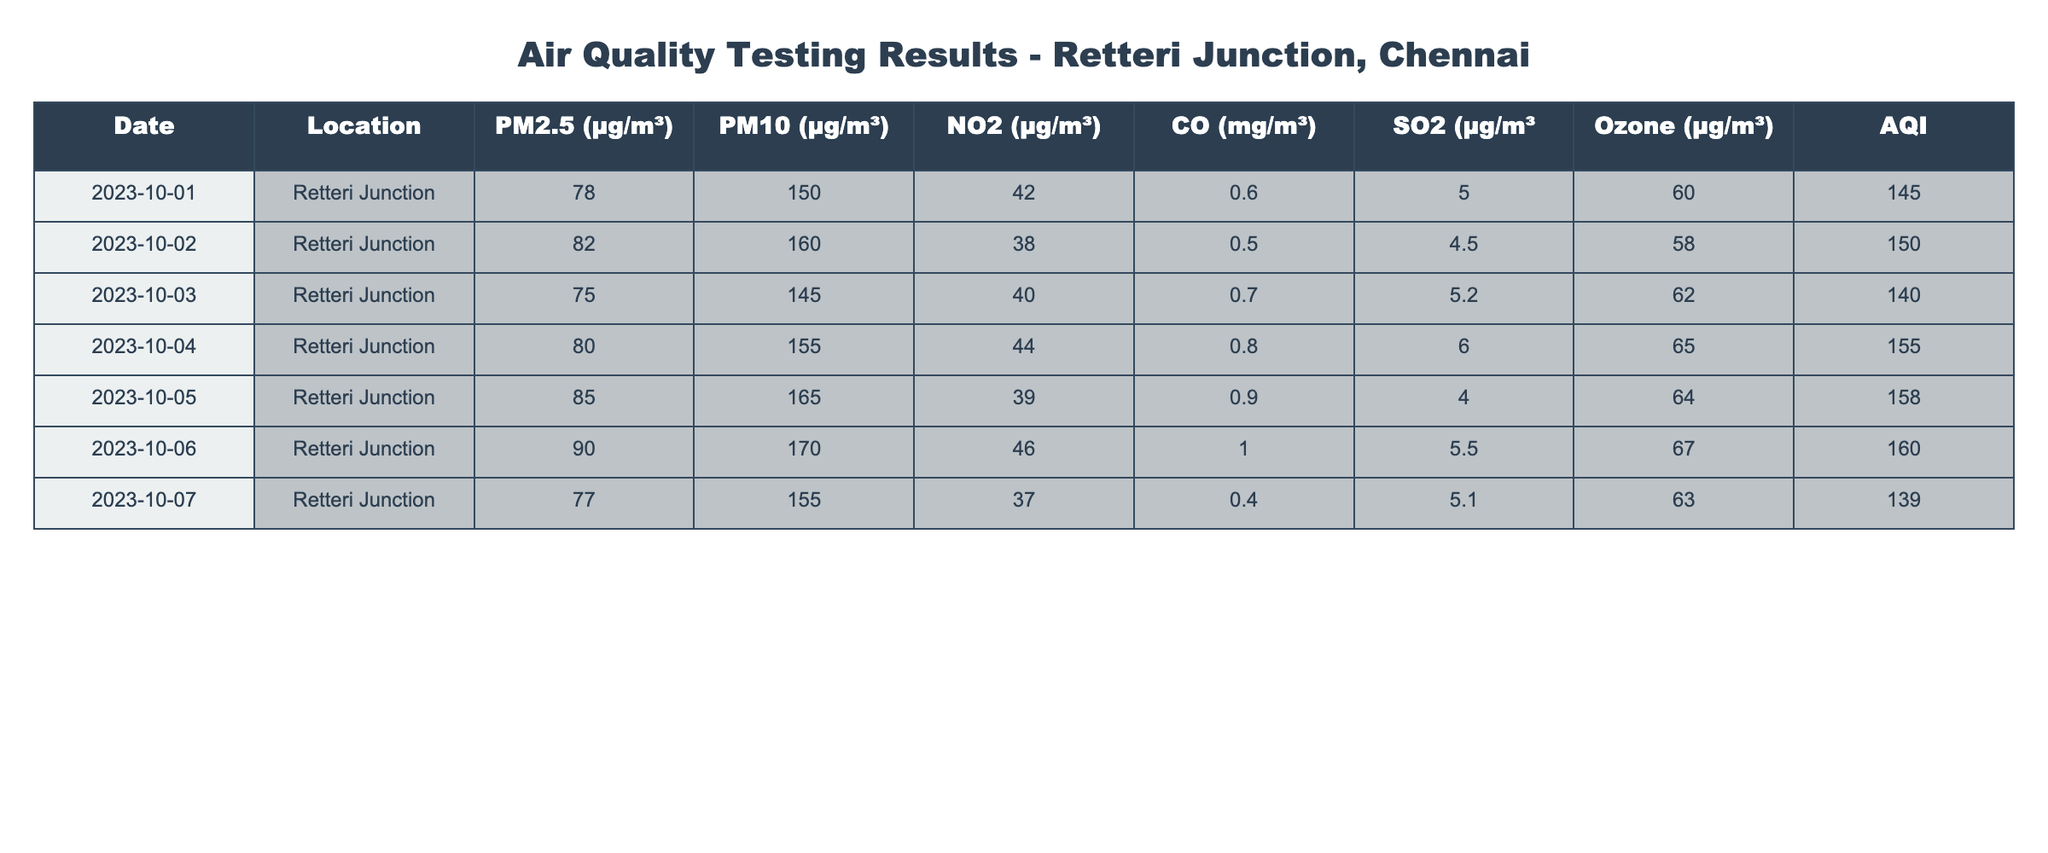What is the highest recorded PM2.5 level at Retteri Junction? The table lists PM2.5 values for each date. The highest value can be found by scanning the PM2.5 column row by row, which shows that the maximum PM2.5 concentration recorded is 90 µg/m³ on October 6, 2023.
Answer: 90 µg/m³ During which date was the AQI the highest? The AQI column needs to be checked for the date with the highest value. Scanning through the AQI values reveals that October 6, 2023, has the highest AQI at 160.
Answer: October 6, 2023 What is the average PM10 value for the recorded days? To find the average, add all PM10 values together (150 + 160 + 145 + 155 + 165 + 170 + 155 = 1,100) and divide by the number of entries (7). Thus, 1,100 / 7 = approximately 157.14.
Answer: 157.14 µg/m³ Is the average NO2 level above 40 µg/m³? First, sum the NO2 values (42 + 38 + 40 + 44 + 39 + 46 + 37 = 286) and then divide by the number of entries (7). This results in an average of 286 / 7 = 40.86. The average is indeed above 40 µg/m³.
Answer: Yes What was the CO level on October 3, 2023, and how does it compare to the CO level on October 1, 2023? The CO levels for October 3, 2023, and October 1, 2023, are 0.7 mg/m³ and 0.6 mg/m³ respectively. To compare: 0.7 mg/m³ (October 3) is higher than 0.6 mg/m³ (October 1) by 0.1 mg/m³.
Answer: 0.7 mg/m³, higher by 0.1 mg/m³ What is the total concentration of SO2 recorded over the testing days? Summing up the SO2 values (5 + 4.5 + 5.2 + 6 + 4 + 5.5 + 5.1 = 35.3) gives the total concentration of SO2 over seven days.
Answer: 35.3 µg/m³ On which days was the Ozone level above 60 µg/m³? By examining the Ozone column, the days with levels above 60 µg/m³ are October 4 (65), October 5 (64), and October 6 (67). These data points indicate three specific days when Ozone exceeded 60 µg/m³.
Answer: October 4, 5, and 6 